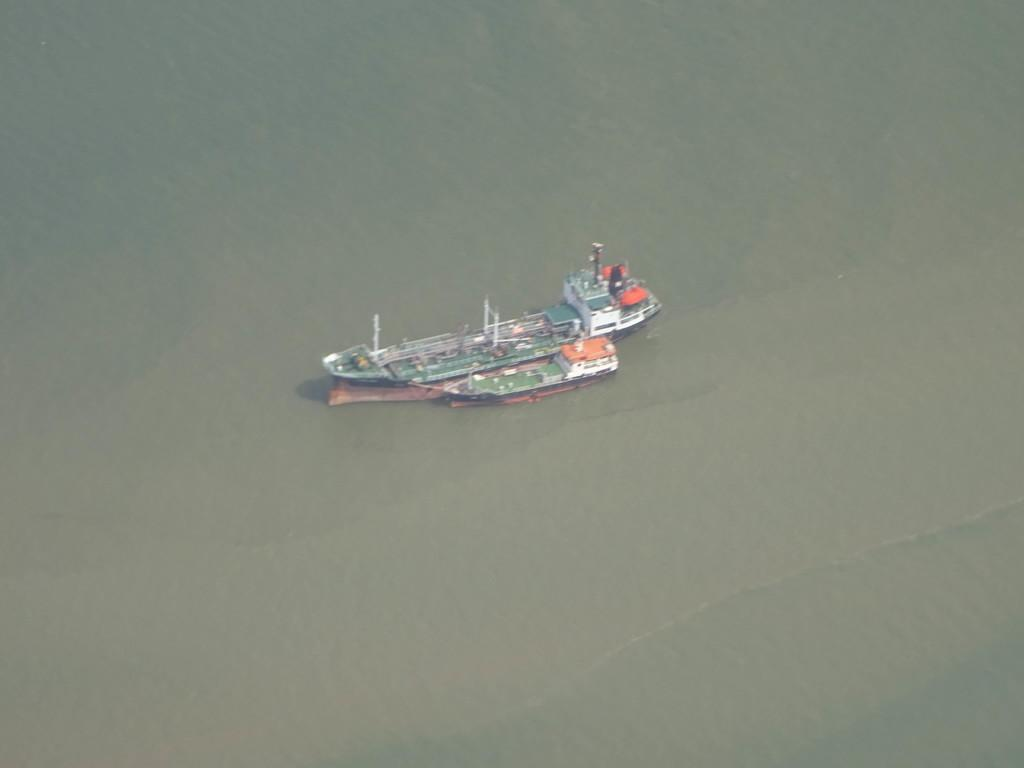What is the main subject of the image? The main subject of the image is a boat. Where is the boat located? The boat is on the water. How is the boat positioned in the image? The boat is in the center of the image. What type of hall can be seen in the background of the image? There is no hall visible in the image; it features a boat on the water. How does the boat compare to the seashore in the image? There is no seashore present in the image; it only shows a boat on the water. 